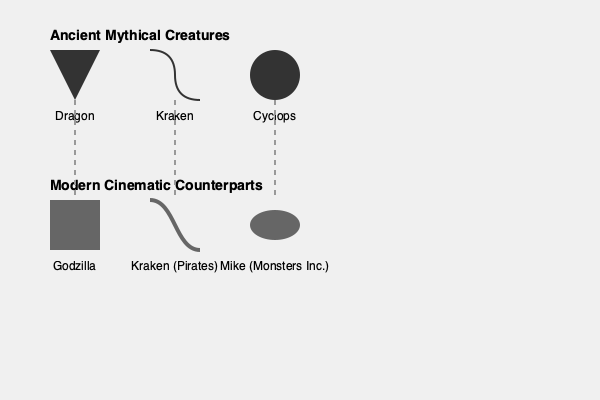Match the silhouettes of ancient mythical creatures with their modern cinematic counterparts. Which pairing represents the evolution of the Cyclops in contemporary cinema? To answer this question, we need to analyze the silhouettes and their corresponding labels, then match the ancient mythical creatures with their modern cinematic counterparts:

1. Dragon: The triangular shape in the ancient row resembles a dragon's head. Its modern counterpart is Godzilla, represented by a rectangular shape, symbolizing the creature's massive, reptilian body.

2. Kraken: The wavy line in the ancient row suggests tentacles, characteristic of the Kraken. This matches with the similar wavy line in the modern row, labeled as "Kraken (Pirates)," referring to the creature from the Pirates of the Caribbean franchise.

3. Cyclops: The circular shape in the ancient row represents the Cyclops, known for its single eye. In the modern row, we see an elliptical shape labeled "Mike (Monsters Inc.)."

Mike from Monsters Inc. is a contemporary reimagining of the Cyclops myth. Like the ancient Cyclops, Mike is characterized by a single, large eye that dominates his appearance. However, unlike the fearsome Cyclops of Greek mythology, Mike is portrayed as a lovable, comedic character, demonstrating how ancient myths can be adapted and transformed in modern cinema.

This pairing showcases how filmmakers have taken the core concept of the Cyclops - a one-eyed creature - and reinterpreted it for a modern, family-friendly audience, while still maintaining the essential visual characteristic that defines the mythological being.
Answer: Cyclops - Mike (Monsters Inc.) 